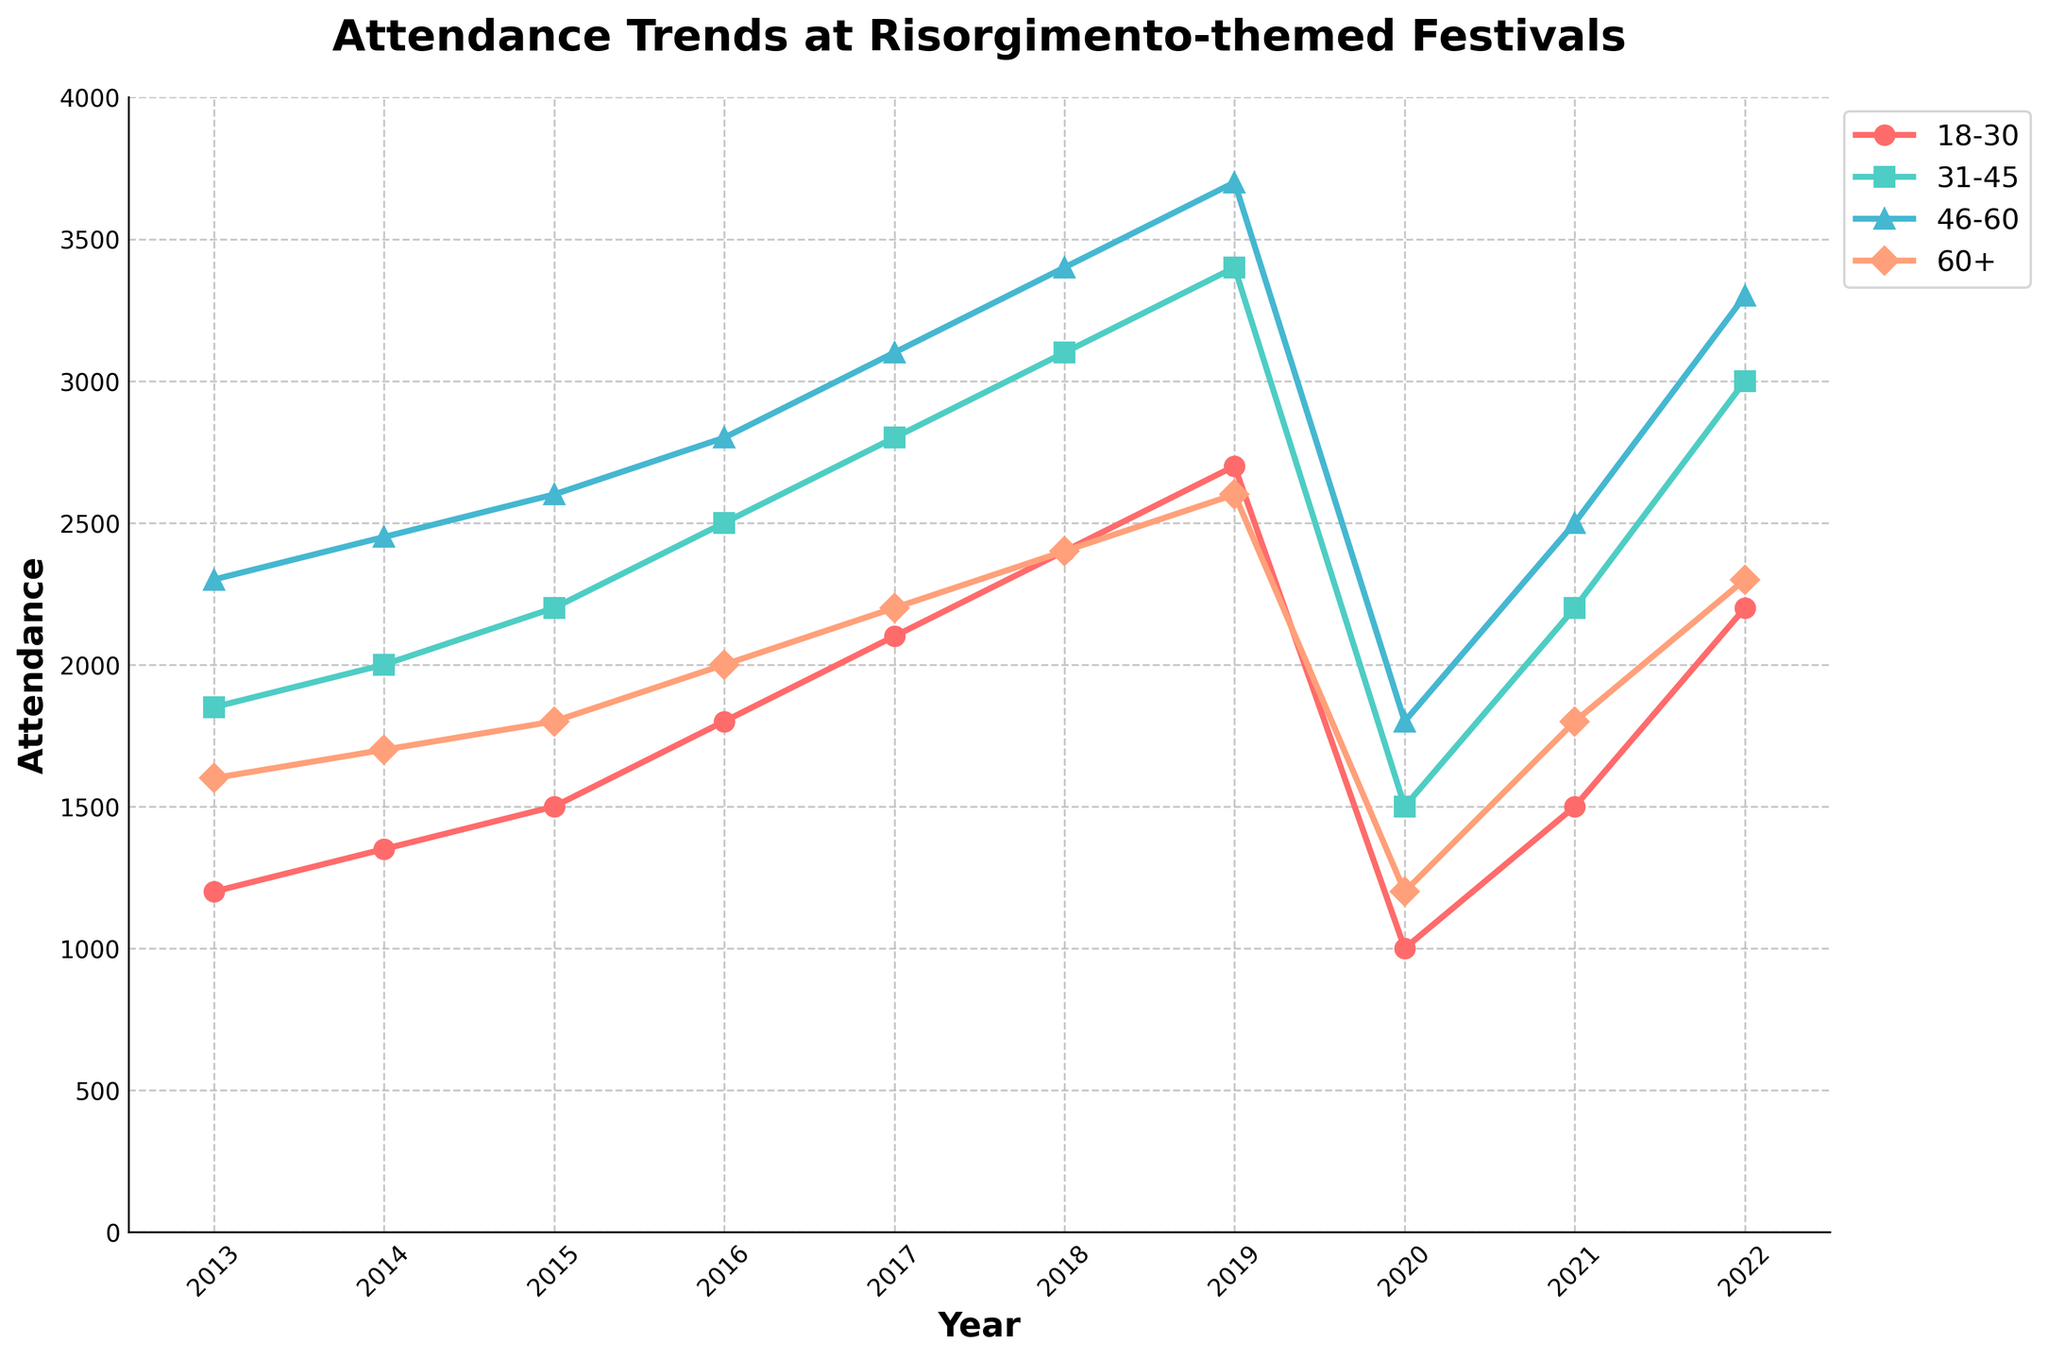How did the attendance for the age group 18-30 change from 2019 to 2020? The attendance for the age group 18-30 in 2019 was 2700 and in 2020 it was 1000. Calculate the difference: 2700 - 1000 = 1700.
Answer: Decreased by 1700 Which age group had the highest attendance in 2016? By looking at the values for 2016, we have: 18-30 (1800), 31-45 (2500), 46-60 (2800), and 60+ (2000). The highest value is 2800, which belongs to the 46-60 age group.
Answer: 46-60 What was the average attendance for all age groups in 2014? The attendance numbers for 2014 are: 18-30 (1350), 31-45 (2000), 46-60 (2450), 60+ (1700). Sum these numbers (1350 + 2000 + 2450 + 1700 = 7500) and then divide by 4.
Answer: 1875 In which year did the age group 31-45 exceed 3000 attendees for the first time? Observing the trend line for the age group 31-45, it exceeded 3000 attendees for the first time in 2018.
Answer: 2018 Which year had the lowest overall attendance for all age groups combined? By adding the values for each year and comparing them, 2020 has the fewest: 18-30 (1000), 31-45 (1500), 46-60 (1800), 60+ (1200). Sum: 1000 + 1500 + 1800 + 1200 = 5500.
Answer: 2020 How many years experienced an increase in attendance for the age group 60+ from the previous year? Comparing each consecutive year for the 60+ age group: 2014, 2015, 2016, 2017, 2018, 2019, and 2022 show increases from their previous years. Total increases: 7 instances.
Answer: 7 What color is used to represent the 31-45 age group in the chart? By observing the legend in the chart, the 31-45 age group is represented by the green-colored line.
Answer: Green How many times did the attendance for the age group 18-30 decline from one year to the next? Observe the year-on-year changes for the 18-30 group: 2020 (2019 to 2020), none other. Total declines: 1.
Answer: 1 What is the difference in attendance for the age group 46-60 between 2017 and 2022? The attendance for the age group 46-60 in 2017 was 3100 and in 2022 it was 3300. Calculate the difference: 3300 - 3100 = 200.
Answer: Increased by 200 